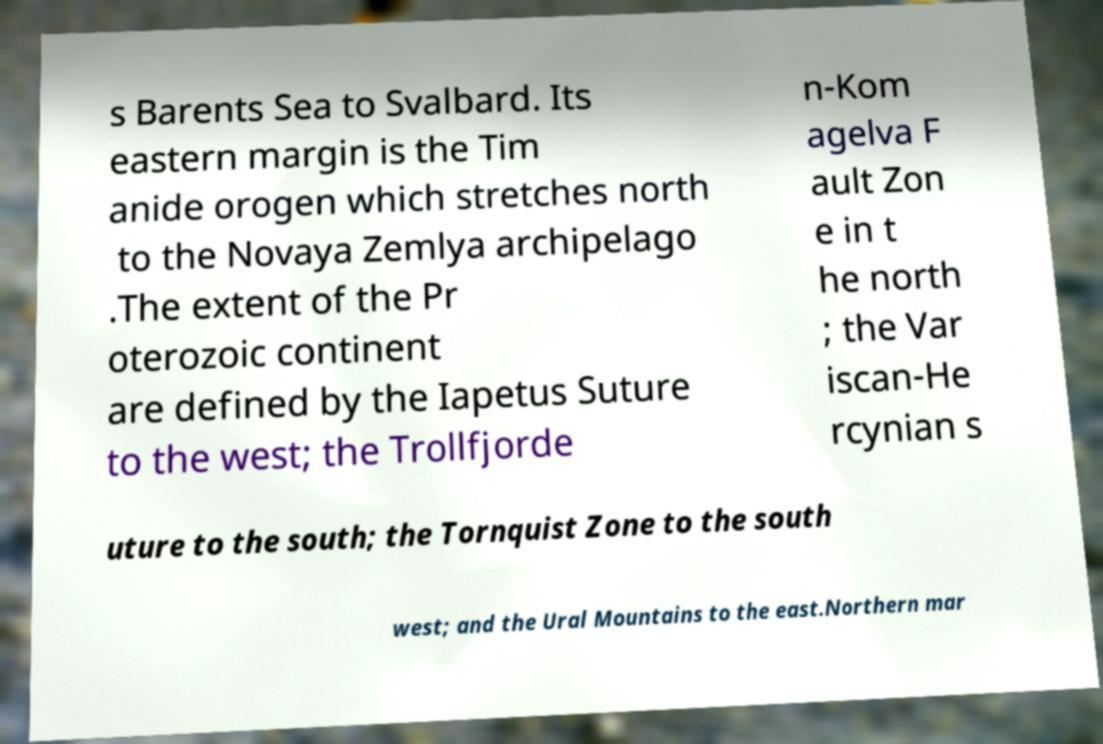Could you extract and type out the text from this image? s Barents Sea to Svalbard. Its eastern margin is the Tim anide orogen which stretches north to the Novaya Zemlya archipelago .The extent of the Pr oterozoic continent are defined by the Iapetus Suture to the west; the Trollfjorde n-Kom agelva F ault Zon e in t he north ; the Var iscan-He rcynian s uture to the south; the Tornquist Zone to the south west; and the Ural Mountains to the east.Northern mar 